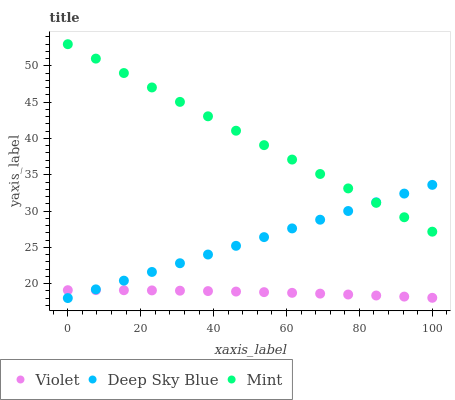Does Violet have the minimum area under the curve?
Answer yes or no. Yes. Does Mint have the maximum area under the curve?
Answer yes or no. Yes. Does Deep Sky Blue have the minimum area under the curve?
Answer yes or no. No. Does Deep Sky Blue have the maximum area under the curve?
Answer yes or no. No. Is Deep Sky Blue the smoothest?
Answer yes or no. Yes. Is Violet the roughest?
Answer yes or no. Yes. Is Violet the smoothest?
Answer yes or no. No. Is Deep Sky Blue the roughest?
Answer yes or no. No. Does Deep Sky Blue have the lowest value?
Answer yes or no. Yes. Does Violet have the lowest value?
Answer yes or no. No. Does Mint have the highest value?
Answer yes or no. Yes. Does Deep Sky Blue have the highest value?
Answer yes or no. No. Is Violet less than Mint?
Answer yes or no. Yes. Is Mint greater than Violet?
Answer yes or no. Yes. Does Mint intersect Deep Sky Blue?
Answer yes or no. Yes. Is Mint less than Deep Sky Blue?
Answer yes or no. No. Is Mint greater than Deep Sky Blue?
Answer yes or no. No. Does Violet intersect Mint?
Answer yes or no. No. 